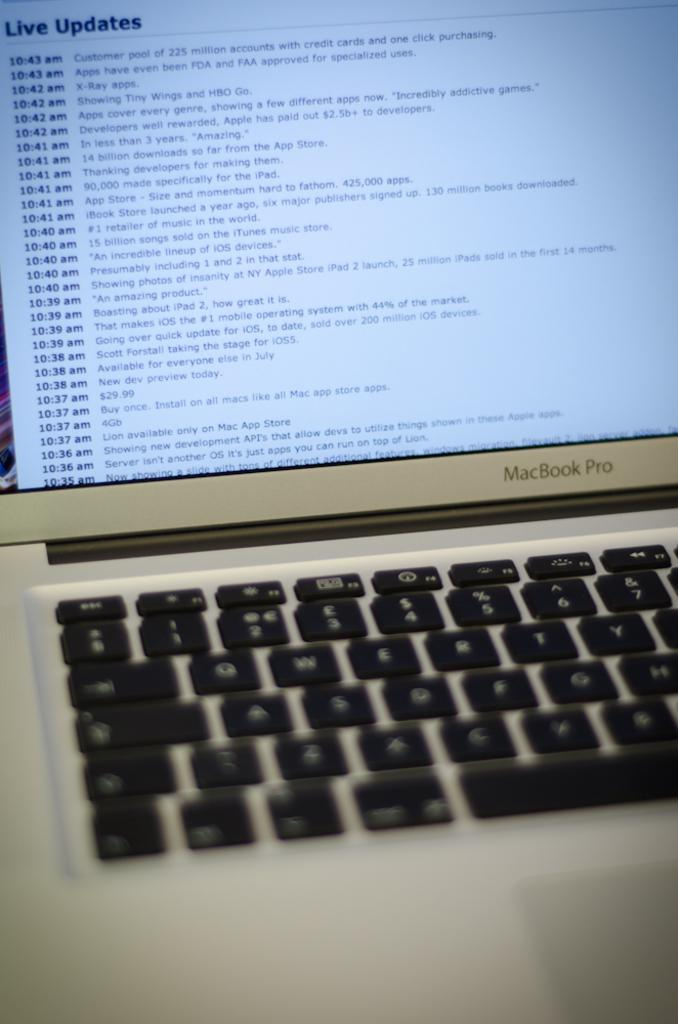<image>
Summarize the visual content of the image. Macbook pro laptop is getting an live update 